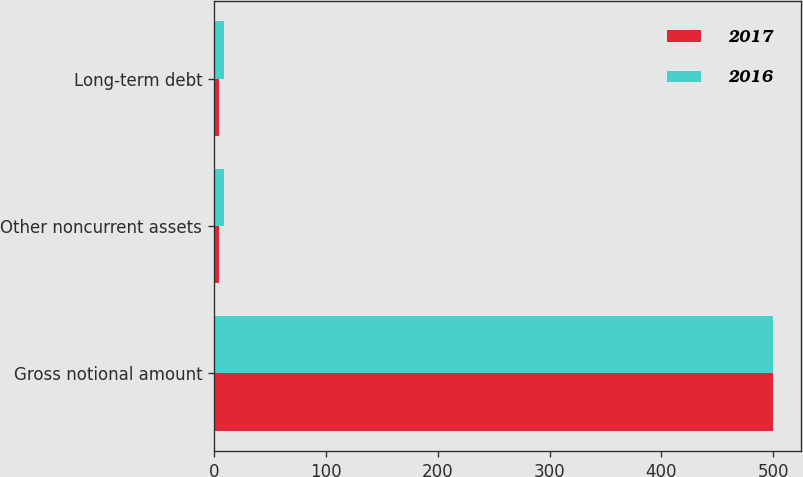Convert chart to OTSL. <chart><loc_0><loc_0><loc_500><loc_500><stacked_bar_chart><ecel><fcel>Gross notional amount<fcel>Other noncurrent assets<fcel>Long-term debt<nl><fcel>2017<fcel>500<fcel>5<fcel>5<nl><fcel>2016<fcel>500<fcel>9<fcel>9<nl></chart> 